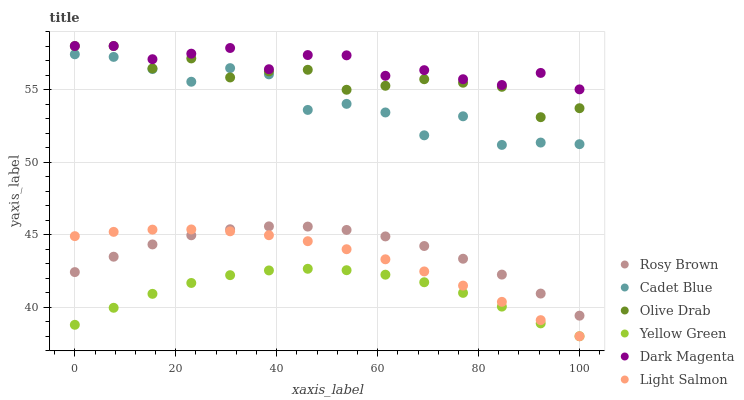Does Yellow Green have the minimum area under the curve?
Answer yes or no. Yes. Does Dark Magenta have the maximum area under the curve?
Answer yes or no. Yes. Does Cadet Blue have the minimum area under the curve?
Answer yes or no. No. Does Cadet Blue have the maximum area under the curve?
Answer yes or no. No. Is Light Salmon the smoothest?
Answer yes or no. Yes. Is Cadet Blue the roughest?
Answer yes or no. Yes. Is Yellow Green the smoothest?
Answer yes or no. No. Is Yellow Green the roughest?
Answer yes or no. No. Does Light Salmon have the lowest value?
Answer yes or no. Yes. Does Cadet Blue have the lowest value?
Answer yes or no. No. Does Dark Magenta have the highest value?
Answer yes or no. Yes. Does Cadet Blue have the highest value?
Answer yes or no. No. Is Light Salmon less than Cadet Blue?
Answer yes or no. Yes. Is Dark Magenta greater than Cadet Blue?
Answer yes or no. Yes. Does Olive Drab intersect Cadet Blue?
Answer yes or no. Yes. Is Olive Drab less than Cadet Blue?
Answer yes or no. No. Is Olive Drab greater than Cadet Blue?
Answer yes or no. No. Does Light Salmon intersect Cadet Blue?
Answer yes or no. No. 